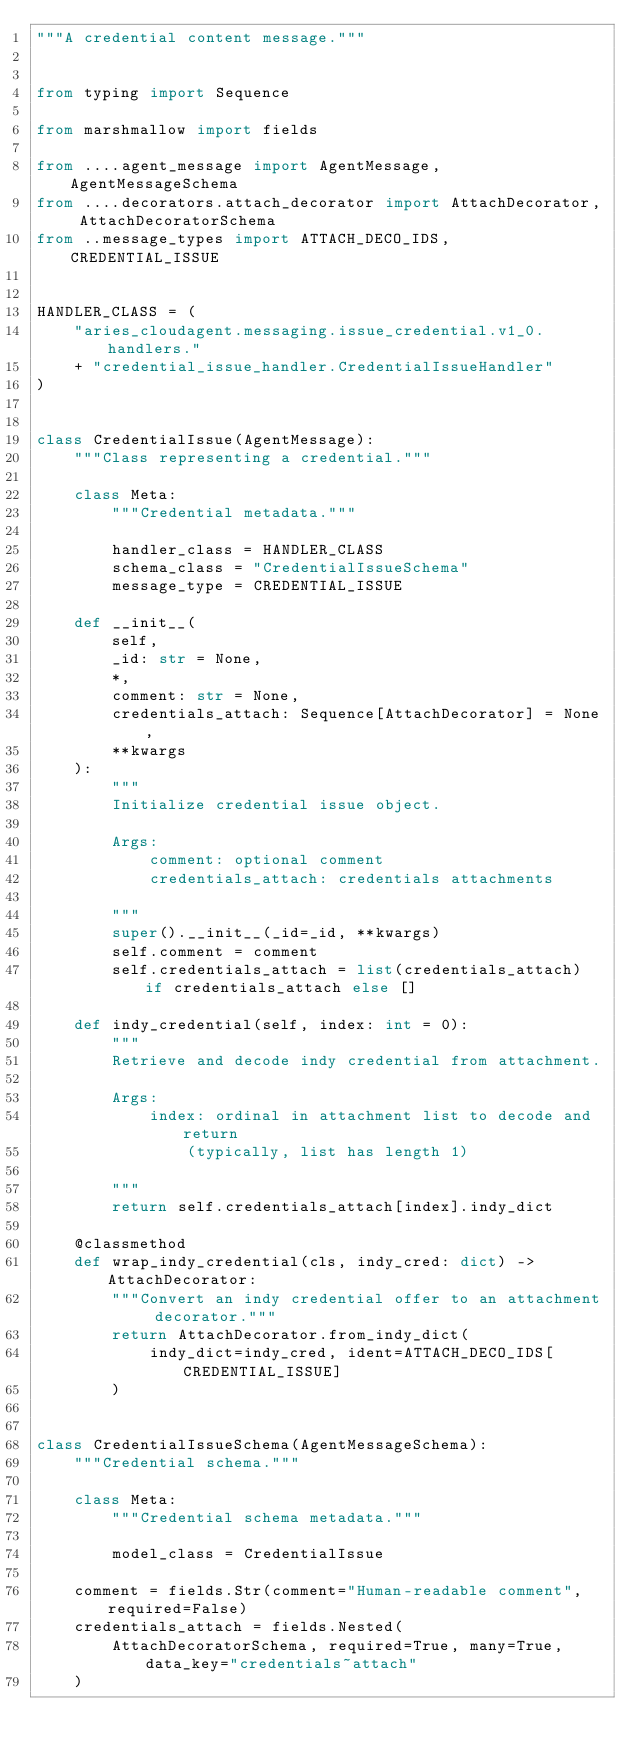Convert code to text. <code><loc_0><loc_0><loc_500><loc_500><_Python_>"""A credential content message."""


from typing import Sequence

from marshmallow import fields

from ....agent_message import AgentMessage, AgentMessageSchema
from ....decorators.attach_decorator import AttachDecorator, AttachDecoratorSchema
from ..message_types import ATTACH_DECO_IDS, CREDENTIAL_ISSUE


HANDLER_CLASS = (
    "aries_cloudagent.messaging.issue_credential.v1_0.handlers."
    + "credential_issue_handler.CredentialIssueHandler"
)


class CredentialIssue(AgentMessage):
    """Class representing a credential."""

    class Meta:
        """Credential metadata."""

        handler_class = HANDLER_CLASS
        schema_class = "CredentialIssueSchema"
        message_type = CREDENTIAL_ISSUE

    def __init__(
        self,
        _id: str = None,
        *,
        comment: str = None,
        credentials_attach: Sequence[AttachDecorator] = None,
        **kwargs
    ):
        """
        Initialize credential issue object.

        Args:
            comment: optional comment
            credentials_attach: credentials attachments

        """
        super().__init__(_id=_id, **kwargs)
        self.comment = comment
        self.credentials_attach = list(credentials_attach) if credentials_attach else []

    def indy_credential(self, index: int = 0):
        """
        Retrieve and decode indy credential from attachment.

        Args:
            index: ordinal in attachment list to decode and return
                (typically, list has length 1)

        """
        return self.credentials_attach[index].indy_dict

    @classmethod
    def wrap_indy_credential(cls, indy_cred: dict) -> AttachDecorator:
        """Convert an indy credential offer to an attachment decorator."""
        return AttachDecorator.from_indy_dict(
            indy_dict=indy_cred, ident=ATTACH_DECO_IDS[CREDENTIAL_ISSUE]
        )


class CredentialIssueSchema(AgentMessageSchema):
    """Credential schema."""

    class Meta:
        """Credential schema metadata."""

        model_class = CredentialIssue

    comment = fields.Str(comment="Human-readable comment", required=False)
    credentials_attach = fields.Nested(
        AttachDecoratorSchema, required=True, many=True, data_key="credentials~attach"
    )
</code> 